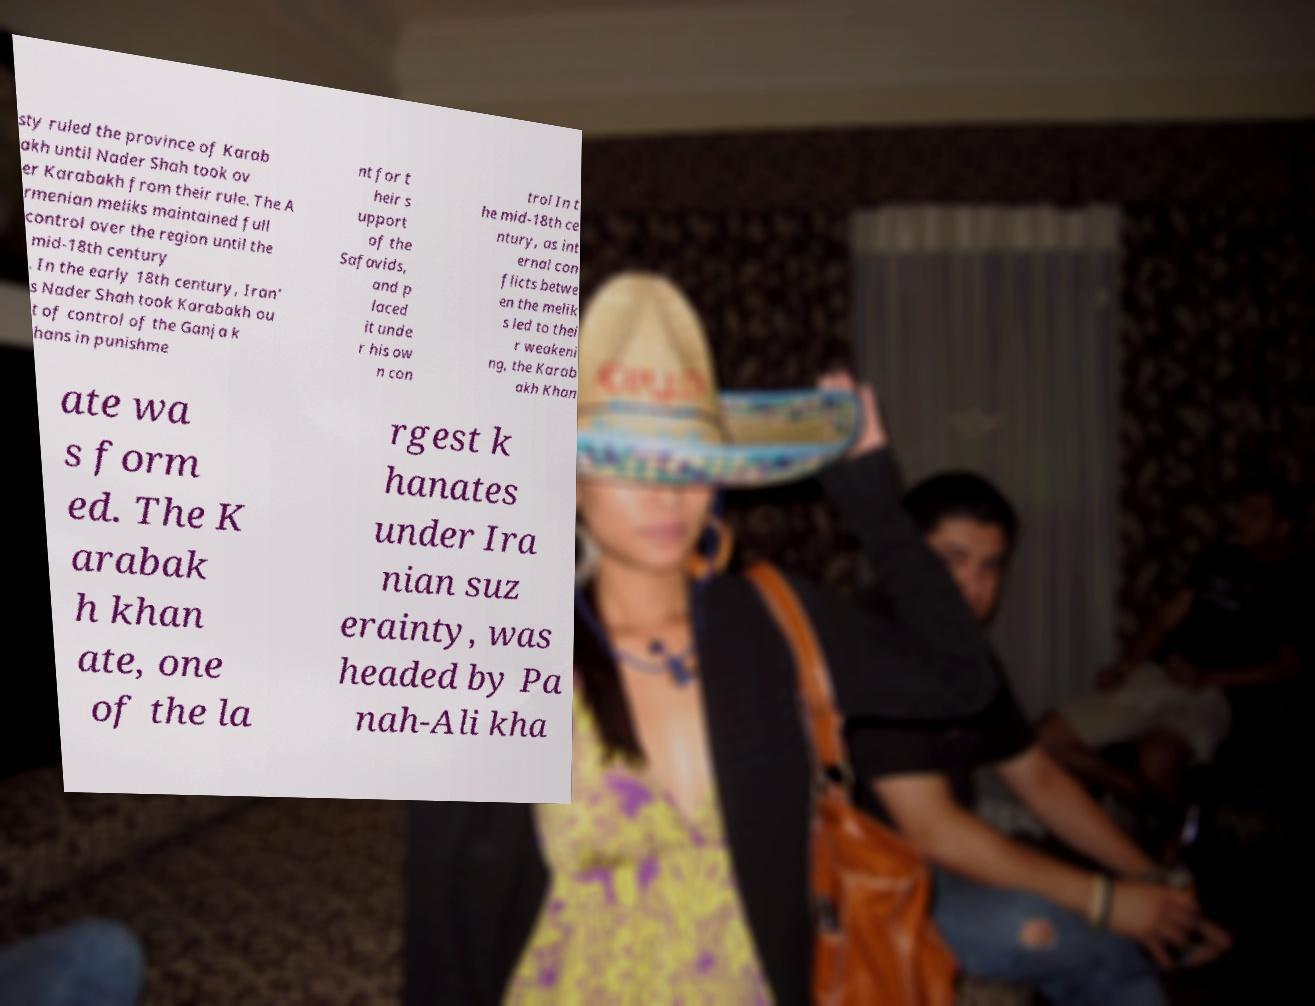Can you read and provide the text displayed in the image?This photo seems to have some interesting text. Can you extract and type it out for me? sty ruled the province of Karab akh until Nader Shah took ov er Karabakh from their rule. The A rmenian meliks maintained full control over the region until the mid-18th century . In the early 18th century, Iran' s Nader Shah took Karabakh ou t of control of the Ganja k hans in punishme nt for t heir s upport of the Safavids, and p laced it unde r his ow n con trol In t he mid-18th ce ntury, as int ernal con flicts betwe en the melik s led to thei r weakeni ng, the Karab akh Khan ate wa s form ed. The K arabak h khan ate, one of the la rgest k hanates under Ira nian suz erainty, was headed by Pa nah-Ali kha 